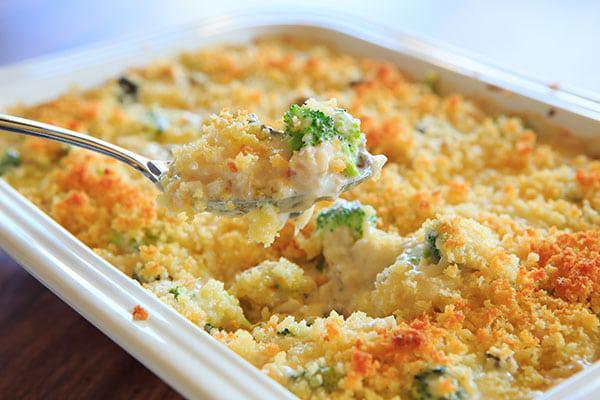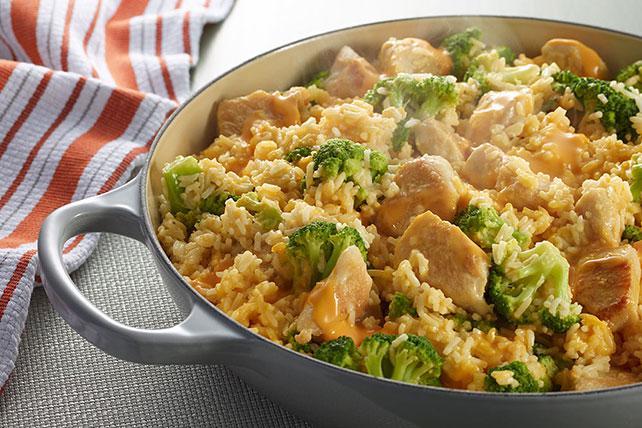The first image is the image on the left, the second image is the image on the right. Assess this claim about the two images: "A meal is served on a red container.". Correct or not? Answer yes or no. No. 